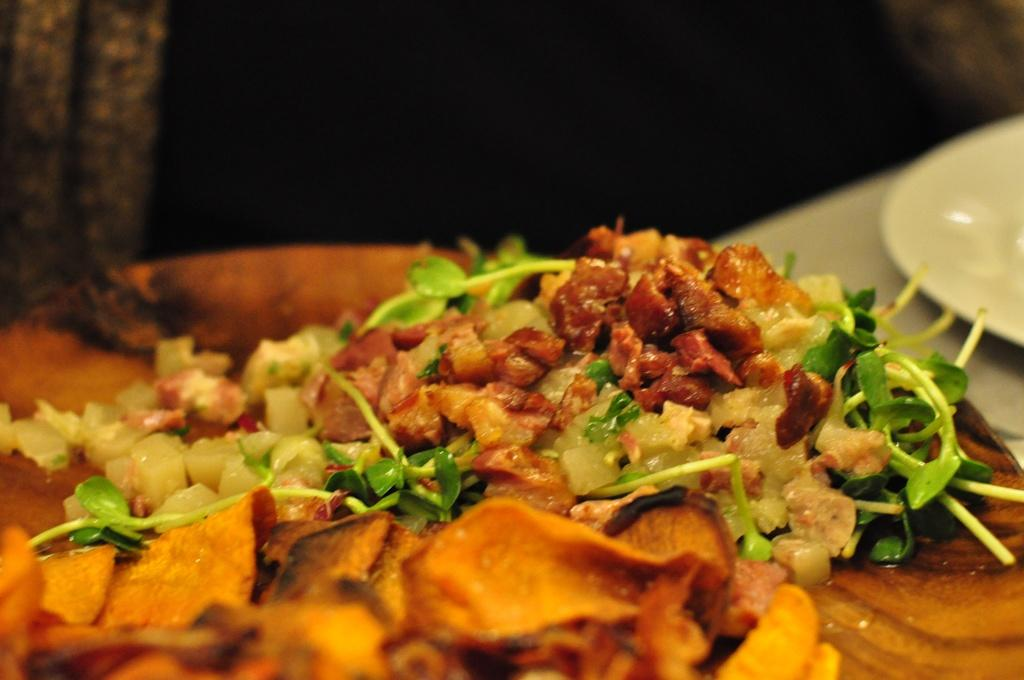What objects are present on the plates in the image? There is food on the plates in the image. What can be observed about the overall appearance of the image? The background of the image is dark. How many spiders are crawling on the plates in the image? There are no spiders present on the plates in the image. What type of chicken is featured in the food on the plates? There is no chicken mentioned or visible in the food on the plates in the image. 